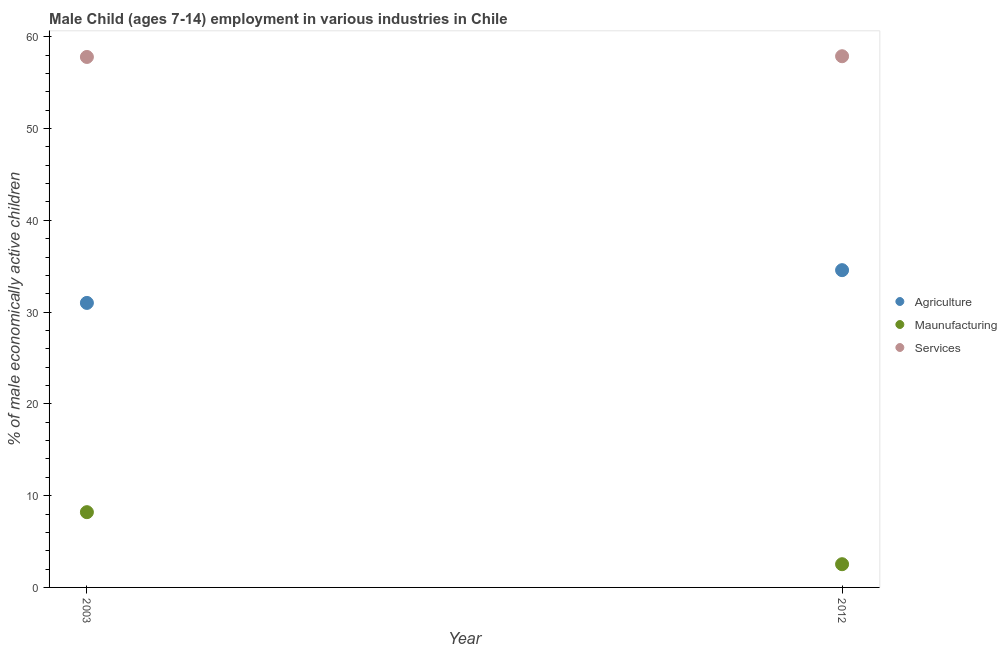What is the percentage of economically active children in services in 2003?
Make the answer very short. 57.8. Across all years, what is the maximum percentage of economically active children in agriculture?
Ensure brevity in your answer.  34.57. Across all years, what is the minimum percentage of economically active children in manufacturing?
Make the answer very short. 2.53. What is the total percentage of economically active children in agriculture in the graph?
Make the answer very short. 65.57. What is the difference between the percentage of economically active children in services in 2003 and that in 2012?
Provide a succinct answer. -0.08. What is the difference between the percentage of economically active children in services in 2003 and the percentage of economically active children in agriculture in 2012?
Provide a short and direct response. 23.23. What is the average percentage of economically active children in services per year?
Give a very brief answer. 57.84. In the year 2003, what is the difference between the percentage of economically active children in agriculture and percentage of economically active children in services?
Your response must be concise. -26.8. What is the ratio of the percentage of economically active children in services in 2003 to that in 2012?
Your response must be concise. 1. Is the percentage of economically active children in manufacturing in 2003 less than that in 2012?
Make the answer very short. No. In how many years, is the percentage of economically active children in manufacturing greater than the average percentage of economically active children in manufacturing taken over all years?
Your answer should be very brief. 1. Is it the case that in every year, the sum of the percentage of economically active children in agriculture and percentage of economically active children in manufacturing is greater than the percentage of economically active children in services?
Make the answer very short. No. Is the percentage of economically active children in services strictly less than the percentage of economically active children in manufacturing over the years?
Your answer should be compact. No. What is the difference between two consecutive major ticks on the Y-axis?
Provide a short and direct response. 10. Are the values on the major ticks of Y-axis written in scientific E-notation?
Provide a succinct answer. No. Does the graph contain any zero values?
Provide a short and direct response. No. Does the graph contain grids?
Your answer should be very brief. No. How are the legend labels stacked?
Provide a succinct answer. Vertical. What is the title of the graph?
Your response must be concise. Male Child (ages 7-14) employment in various industries in Chile. What is the label or title of the X-axis?
Give a very brief answer. Year. What is the label or title of the Y-axis?
Provide a short and direct response. % of male economically active children. What is the % of male economically active children of Agriculture in 2003?
Ensure brevity in your answer.  31. What is the % of male economically active children in Maunufacturing in 2003?
Make the answer very short. 8.2. What is the % of male economically active children of Services in 2003?
Offer a terse response. 57.8. What is the % of male economically active children of Agriculture in 2012?
Make the answer very short. 34.57. What is the % of male economically active children of Maunufacturing in 2012?
Your response must be concise. 2.53. What is the % of male economically active children in Services in 2012?
Your answer should be compact. 57.88. Across all years, what is the maximum % of male economically active children in Agriculture?
Keep it short and to the point. 34.57. Across all years, what is the maximum % of male economically active children of Maunufacturing?
Give a very brief answer. 8.2. Across all years, what is the maximum % of male economically active children in Services?
Make the answer very short. 57.88. Across all years, what is the minimum % of male economically active children of Maunufacturing?
Provide a succinct answer. 2.53. Across all years, what is the minimum % of male economically active children of Services?
Provide a succinct answer. 57.8. What is the total % of male economically active children in Agriculture in the graph?
Ensure brevity in your answer.  65.57. What is the total % of male economically active children of Maunufacturing in the graph?
Provide a succinct answer. 10.73. What is the total % of male economically active children in Services in the graph?
Your answer should be very brief. 115.68. What is the difference between the % of male economically active children of Agriculture in 2003 and that in 2012?
Make the answer very short. -3.57. What is the difference between the % of male economically active children of Maunufacturing in 2003 and that in 2012?
Your answer should be very brief. 5.67. What is the difference between the % of male economically active children in Services in 2003 and that in 2012?
Your answer should be very brief. -0.08. What is the difference between the % of male economically active children in Agriculture in 2003 and the % of male economically active children in Maunufacturing in 2012?
Ensure brevity in your answer.  28.47. What is the difference between the % of male economically active children of Agriculture in 2003 and the % of male economically active children of Services in 2012?
Keep it short and to the point. -26.88. What is the difference between the % of male economically active children in Maunufacturing in 2003 and the % of male economically active children in Services in 2012?
Offer a terse response. -49.68. What is the average % of male economically active children in Agriculture per year?
Offer a very short reply. 32.78. What is the average % of male economically active children in Maunufacturing per year?
Ensure brevity in your answer.  5.37. What is the average % of male economically active children in Services per year?
Make the answer very short. 57.84. In the year 2003, what is the difference between the % of male economically active children of Agriculture and % of male economically active children of Maunufacturing?
Your answer should be compact. 22.8. In the year 2003, what is the difference between the % of male economically active children in Agriculture and % of male economically active children in Services?
Provide a short and direct response. -26.8. In the year 2003, what is the difference between the % of male economically active children of Maunufacturing and % of male economically active children of Services?
Your response must be concise. -49.6. In the year 2012, what is the difference between the % of male economically active children in Agriculture and % of male economically active children in Maunufacturing?
Keep it short and to the point. 32.04. In the year 2012, what is the difference between the % of male economically active children in Agriculture and % of male economically active children in Services?
Ensure brevity in your answer.  -23.31. In the year 2012, what is the difference between the % of male economically active children of Maunufacturing and % of male economically active children of Services?
Provide a succinct answer. -55.35. What is the ratio of the % of male economically active children of Agriculture in 2003 to that in 2012?
Ensure brevity in your answer.  0.9. What is the ratio of the % of male economically active children in Maunufacturing in 2003 to that in 2012?
Your answer should be very brief. 3.24. What is the ratio of the % of male economically active children in Services in 2003 to that in 2012?
Ensure brevity in your answer.  1. What is the difference between the highest and the second highest % of male economically active children in Agriculture?
Your answer should be very brief. 3.57. What is the difference between the highest and the second highest % of male economically active children in Maunufacturing?
Your response must be concise. 5.67. What is the difference between the highest and the second highest % of male economically active children in Services?
Make the answer very short. 0.08. What is the difference between the highest and the lowest % of male economically active children of Agriculture?
Your response must be concise. 3.57. What is the difference between the highest and the lowest % of male economically active children in Maunufacturing?
Ensure brevity in your answer.  5.67. 